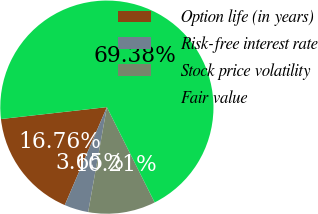Convert chart to OTSL. <chart><loc_0><loc_0><loc_500><loc_500><pie_chart><fcel>Option life (in years)<fcel>Risk-free interest rate<fcel>Stock price volatility<fcel>Fair value<nl><fcel>16.76%<fcel>3.65%<fcel>10.21%<fcel>69.38%<nl></chart> 